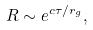Convert formula to latex. <formula><loc_0><loc_0><loc_500><loc_500>R \sim e ^ { c \tau / r _ { g } } ,</formula> 